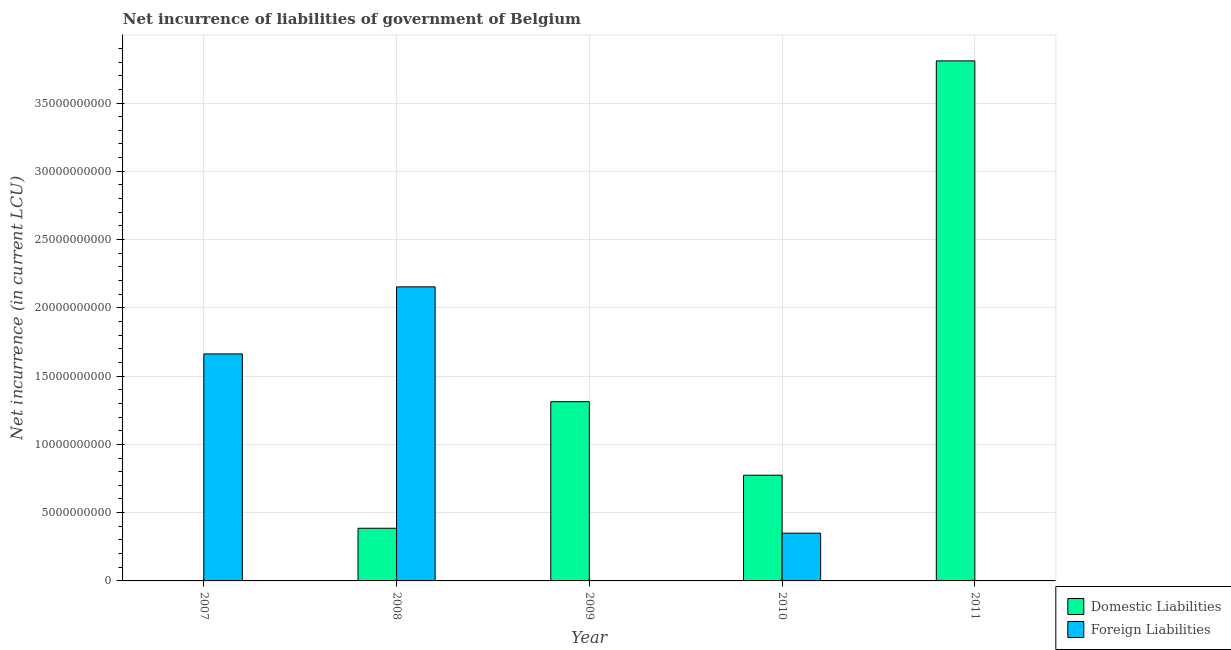How many different coloured bars are there?
Your answer should be very brief. 2. Are the number of bars per tick equal to the number of legend labels?
Your answer should be very brief. No. Are the number of bars on each tick of the X-axis equal?
Provide a short and direct response. No. How many bars are there on the 4th tick from the left?
Your answer should be very brief. 2. What is the label of the 4th group of bars from the left?
Your answer should be very brief. 2010. What is the net incurrence of foreign liabilities in 2007?
Provide a succinct answer. 1.66e+1. Across all years, what is the maximum net incurrence of foreign liabilities?
Ensure brevity in your answer.  2.15e+1. Across all years, what is the minimum net incurrence of foreign liabilities?
Ensure brevity in your answer.  0. In which year was the net incurrence of foreign liabilities maximum?
Make the answer very short. 2008. What is the total net incurrence of domestic liabilities in the graph?
Provide a succinct answer. 6.28e+1. What is the difference between the net incurrence of foreign liabilities in 2007 and that in 2010?
Provide a short and direct response. 1.31e+1. What is the difference between the net incurrence of domestic liabilities in 2011 and the net incurrence of foreign liabilities in 2009?
Offer a very short reply. 2.50e+1. What is the average net incurrence of domestic liabilities per year?
Provide a succinct answer. 1.26e+1. In the year 2007, what is the difference between the net incurrence of foreign liabilities and net incurrence of domestic liabilities?
Provide a succinct answer. 0. What is the ratio of the net incurrence of domestic liabilities in 2008 to that in 2009?
Offer a terse response. 0.29. Is the net incurrence of domestic liabilities in 2009 less than that in 2010?
Offer a very short reply. No. Is the difference between the net incurrence of domestic liabilities in 2010 and 2011 greater than the difference between the net incurrence of foreign liabilities in 2010 and 2011?
Keep it short and to the point. No. What is the difference between the highest and the second highest net incurrence of foreign liabilities?
Offer a terse response. 4.91e+09. What is the difference between the highest and the lowest net incurrence of foreign liabilities?
Your answer should be very brief. 2.15e+1. In how many years, is the net incurrence of foreign liabilities greater than the average net incurrence of foreign liabilities taken over all years?
Offer a very short reply. 2. Is the sum of the net incurrence of domestic liabilities in 2010 and 2011 greater than the maximum net incurrence of foreign liabilities across all years?
Make the answer very short. Yes. How many bars are there?
Offer a terse response. 7. How many years are there in the graph?
Provide a short and direct response. 5. Does the graph contain grids?
Your answer should be very brief. Yes. How many legend labels are there?
Your answer should be very brief. 2. What is the title of the graph?
Give a very brief answer. Net incurrence of liabilities of government of Belgium. Does "Age 65(female)" appear as one of the legend labels in the graph?
Offer a very short reply. No. What is the label or title of the Y-axis?
Provide a succinct answer. Net incurrence (in current LCU). What is the Net incurrence (in current LCU) in Foreign Liabilities in 2007?
Provide a succinct answer. 1.66e+1. What is the Net incurrence (in current LCU) in Domestic Liabilities in 2008?
Your answer should be very brief. 3.86e+09. What is the Net incurrence (in current LCU) in Foreign Liabilities in 2008?
Your answer should be compact. 2.15e+1. What is the Net incurrence (in current LCU) in Domestic Liabilities in 2009?
Make the answer very short. 1.31e+1. What is the Net incurrence (in current LCU) in Foreign Liabilities in 2009?
Make the answer very short. 0. What is the Net incurrence (in current LCU) of Domestic Liabilities in 2010?
Your answer should be very brief. 7.74e+09. What is the Net incurrence (in current LCU) in Foreign Liabilities in 2010?
Give a very brief answer. 3.50e+09. What is the Net incurrence (in current LCU) of Domestic Liabilities in 2011?
Provide a succinct answer. 3.81e+1. Across all years, what is the maximum Net incurrence (in current LCU) in Domestic Liabilities?
Provide a succinct answer. 3.81e+1. Across all years, what is the maximum Net incurrence (in current LCU) of Foreign Liabilities?
Your answer should be very brief. 2.15e+1. Across all years, what is the minimum Net incurrence (in current LCU) in Foreign Liabilities?
Ensure brevity in your answer.  0. What is the total Net incurrence (in current LCU) in Domestic Liabilities in the graph?
Give a very brief answer. 6.28e+1. What is the total Net incurrence (in current LCU) in Foreign Liabilities in the graph?
Ensure brevity in your answer.  4.17e+1. What is the difference between the Net incurrence (in current LCU) in Foreign Liabilities in 2007 and that in 2008?
Your answer should be very brief. -4.91e+09. What is the difference between the Net incurrence (in current LCU) in Foreign Liabilities in 2007 and that in 2010?
Provide a succinct answer. 1.31e+1. What is the difference between the Net incurrence (in current LCU) of Domestic Liabilities in 2008 and that in 2009?
Your response must be concise. -9.27e+09. What is the difference between the Net incurrence (in current LCU) in Domestic Liabilities in 2008 and that in 2010?
Keep it short and to the point. -3.88e+09. What is the difference between the Net incurrence (in current LCU) in Foreign Liabilities in 2008 and that in 2010?
Provide a short and direct response. 1.80e+1. What is the difference between the Net incurrence (in current LCU) in Domestic Liabilities in 2008 and that in 2011?
Give a very brief answer. -3.42e+1. What is the difference between the Net incurrence (in current LCU) of Domestic Liabilities in 2009 and that in 2010?
Your response must be concise. 5.39e+09. What is the difference between the Net incurrence (in current LCU) in Domestic Liabilities in 2009 and that in 2011?
Your answer should be compact. -2.50e+1. What is the difference between the Net incurrence (in current LCU) of Domestic Liabilities in 2010 and that in 2011?
Your response must be concise. -3.03e+1. What is the difference between the Net incurrence (in current LCU) in Domestic Liabilities in 2008 and the Net incurrence (in current LCU) in Foreign Liabilities in 2010?
Your answer should be very brief. 3.59e+08. What is the difference between the Net incurrence (in current LCU) of Domestic Liabilities in 2009 and the Net incurrence (in current LCU) of Foreign Liabilities in 2010?
Your response must be concise. 9.63e+09. What is the average Net incurrence (in current LCU) of Domestic Liabilities per year?
Keep it short and to the point. 1.26e+1. What is the average Net incurrence (in current LCU) of Foreign Liabilities per year?
Keep it short and to the point. 8.33e+09. In the year 2008, what is the difference between the Net incurrence (in current LCU) of Domestic Liabilities and Net incurrence (in current LCU) of Foreign Liabilities?
Your response must be concise. -1.77e+1. In the year 2010, what is the difference between the Net incurrence (in current LCU) of Domestic Liabilities and Net incurrence (in current LCU) of Foreign Liabilities?
Offer a terse response. 4.24e+09. What is the ratio of the Net incurrence (in current LCU) of Foreign Liabilities in 2007 to that in 2008?
Provide a succinct answer. 0.77. What is the ratio of the Net incurrence (in current LCU) of Foreign Liabilities in 2007 to that in 2010?
Offer a very short reply. 4.75. What is the ratio of the Net incurrence (in current LCU) of Domestic Liabilities in 2008 to that in 2009?
Keep it short and to the point. 0.29. What is the ratio of the Net incurrence (in current LCU) in Domestic Liabilities in 2008 to that in 2010?
Give a very brief answer. 0.5. What is the ratio of the Net incurrence (in current LCU) in Foreign Liabilities in 2008 to that in 2010?
Make the answer very short. 6.16. What is the ratio of the Net incurrence (in current LCU) in Domestic Liabilities in 2008 to that in 2011?
Your answer should be compact. 0.1. What is the ratio of the Net incurrence (in current LCU) of Domestic Liabilities in 2009 to that in 2010?
Offer a terse response. 1.7. What is the ratio of the Net incurrence (in current LCU) in Domestic Liabilities in 2009 to that in 2011?
Your answer should be compact. 0.34. What is the ratio of the Net incurrence (in current LCU) in Domestic Liabilities in 2010 to that in 2011?
Your answer should be very brief. 0.2. What is the difference between the highest and the second highest Net incurrence (in current LCU) in Domestic Liabilities?
Give a very brief answer. 2.50e+1. What is the difference between the highest and the second highest Net incurrence (in current LCU) of Foreign Liabilities?
Make the answer very short. 4.91e+09. What is the difference between the highest and the lowest Net incurrence (in current LCU) of Domestic Liabilities?
Your answer should be very brief. 3.81e+1. What is the difference between the highest and the lowest Net incurrence (in current LCU) of Foreign Liabilities?
Offer a terse response. 2.15e+1. 